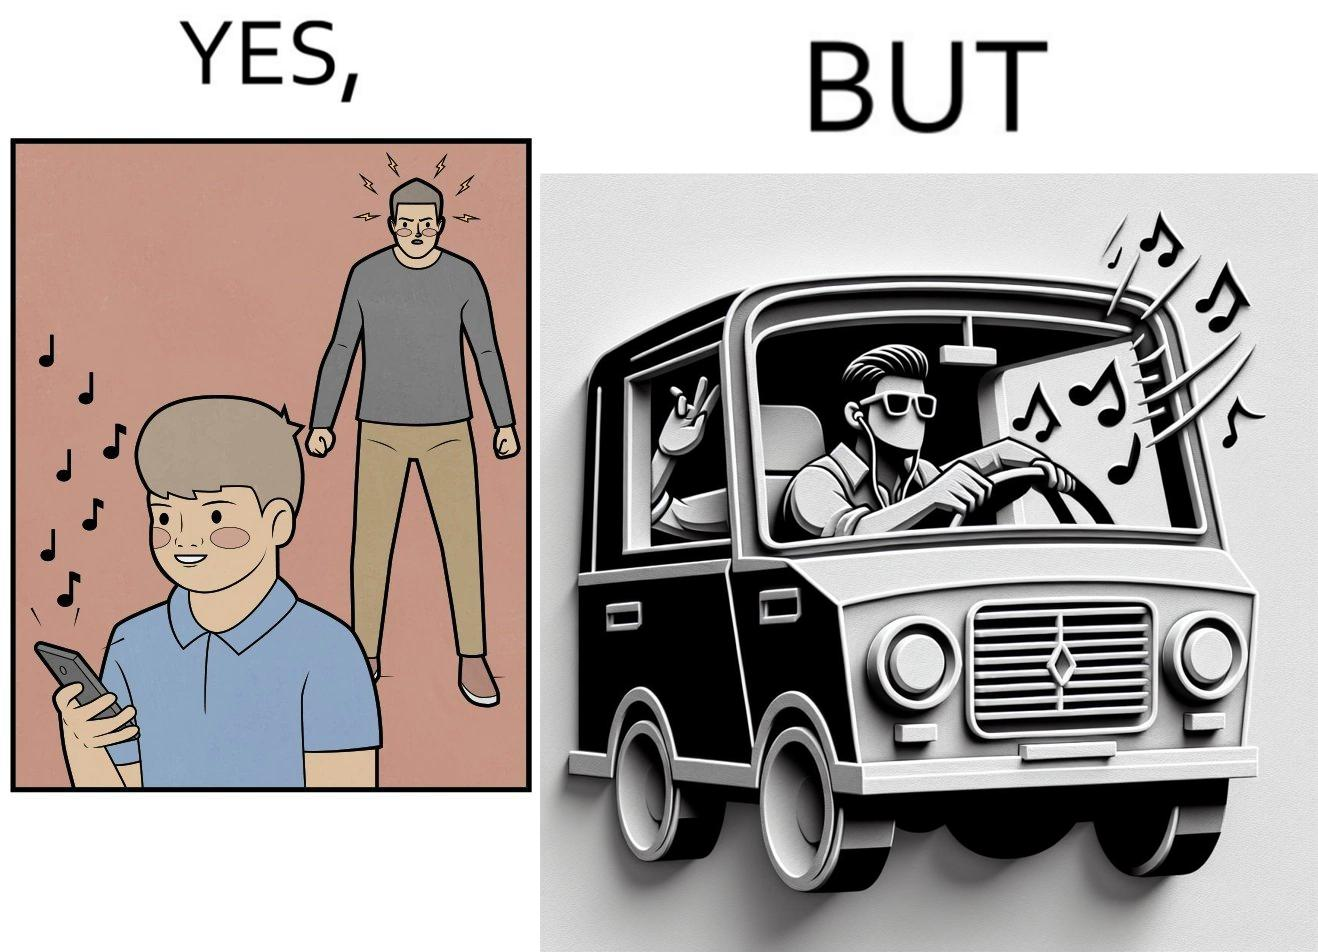Describe the satirical element in this image. The image is funny because while the man does not like the boy playing music loudly on his phone, the man himself is okay with doing the same thing with his car and playing loud music in the car with the sound coming out of the car. 